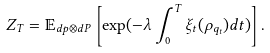Convert formula to latex. <formula><loc_0><loc_0><loc_500><loc_500>Z _ { T } = \mathbb { E } _ { d p \otimes d P } \left [ \exp ( - \lambda \int _ { 0 } ^ { T } \xi _ { t } ( \rho _ { q _ { t } } ) d t ) \right ] .</formula> 